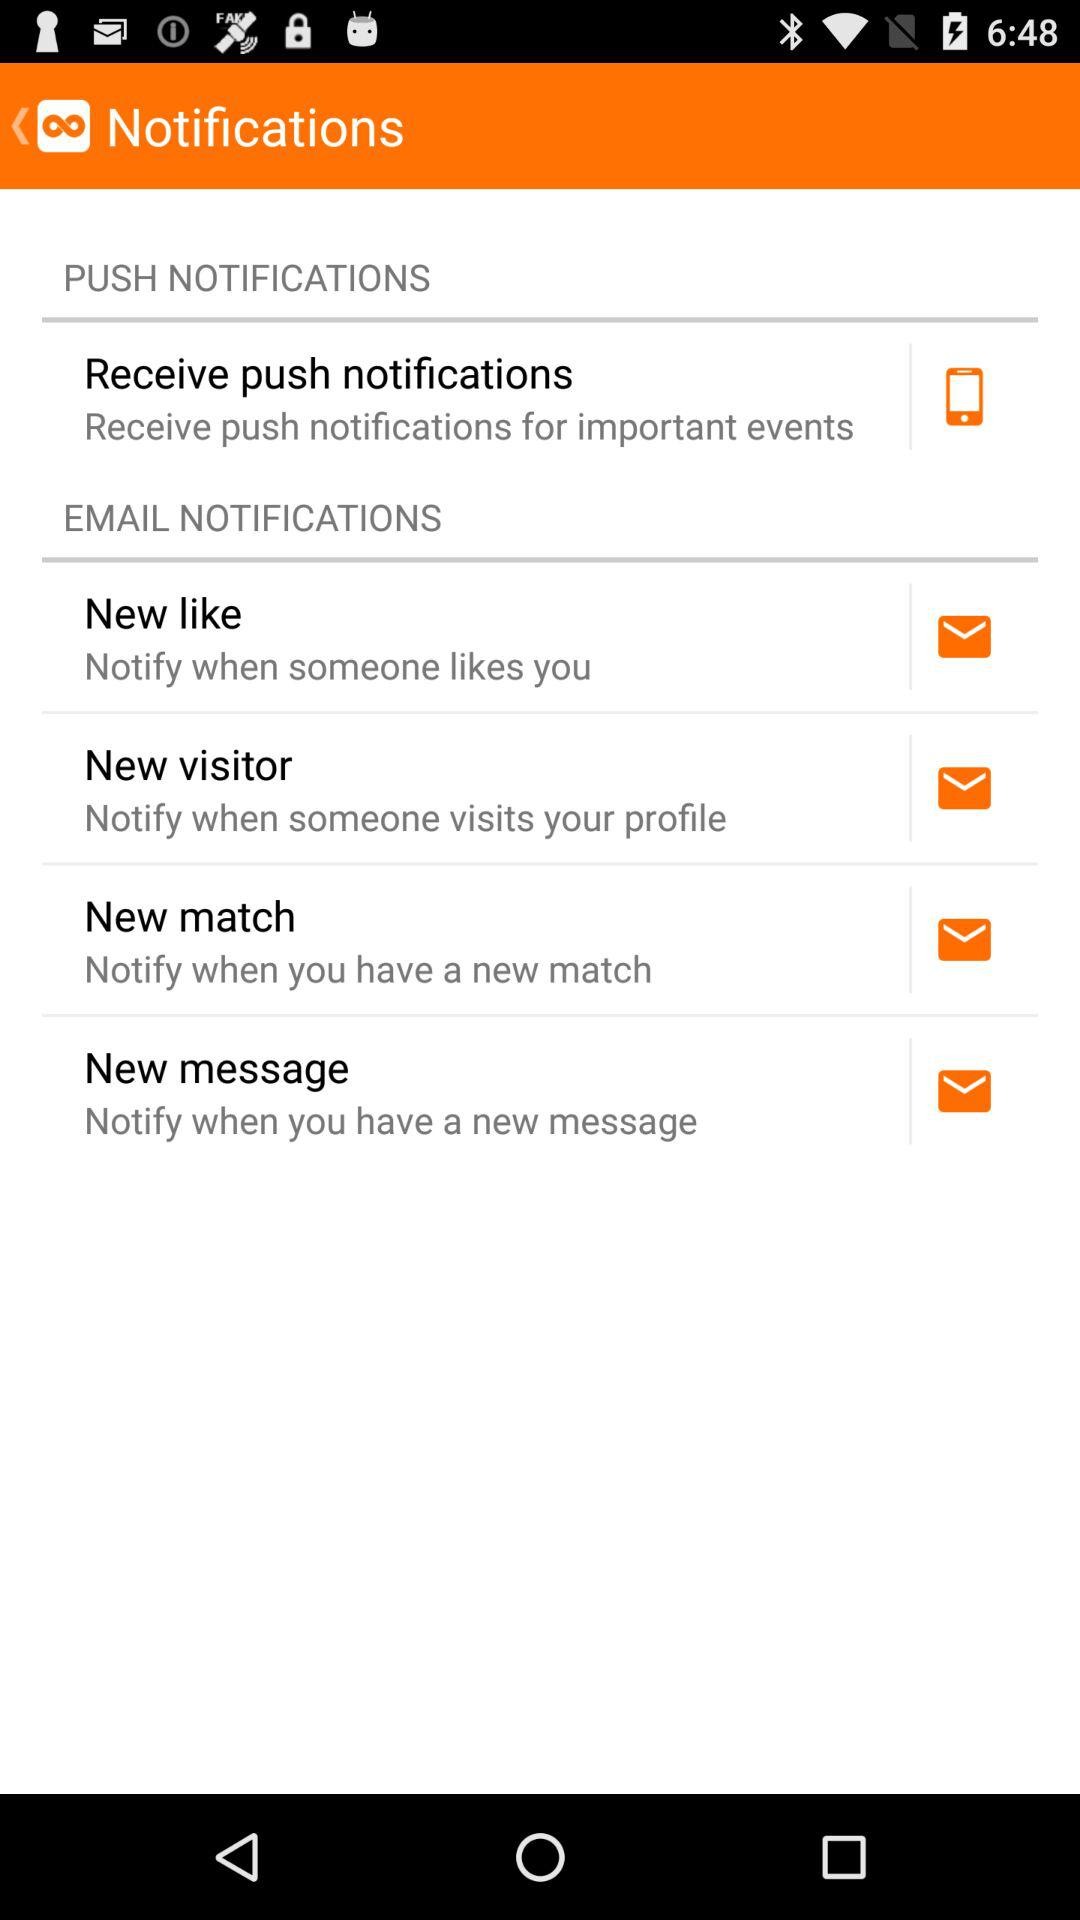What is the status of the new like?
When the provided information is insufficient, respond with <no answer>. <no answer> 